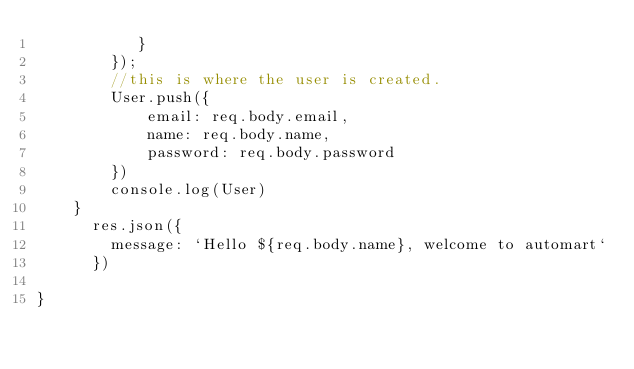Convert code to text. <code><loc_0><loc_0><loc_500><loc_500><_JavaScript_>           }
        });
        //this is where the user is created.
        User.push({
            email: req.body.email,
            name: req.body.name,
            password: req.body.password
        })
        console.log(User)
    }
      res.json({
        message: `Hello ${req.body.name}, welcome to automart`
      })
    
}</code> 